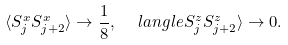<formula> <loc_0><loc_0><loc_500><loc_500>\langle S _ { j } ^ { x } S _ { j + 2 } ^ { x } \rangle \to \frac { 1 } { 8 } , \ \ \ l a n g l e S _ { j } ^ { z } S _ { j + 2 } ^ { z } \rangle \to 0 .</formula> 